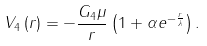<formula> <loc_0><loc_0><loc_500><loc_500>V _ { 4 } \left ( r \right ) = - \frac { G _ { 4 } \mu } { r } \left ( 1 + \alpha e ^ { - \frac { r } { \lambda } } \right ) .</formula> 